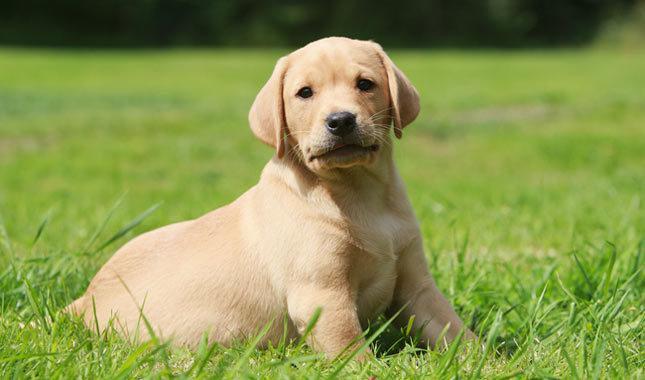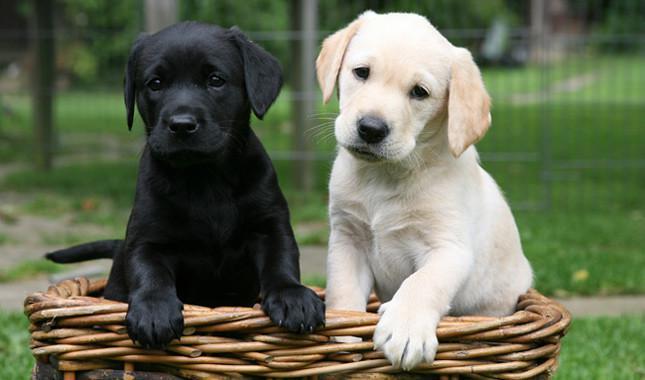The first image is the image on the left, the second image is the image on the right. Analyze the images presented: Is the assertion "There are no more than four labrador retrievers" valid? Answer yes or no. Yes. 